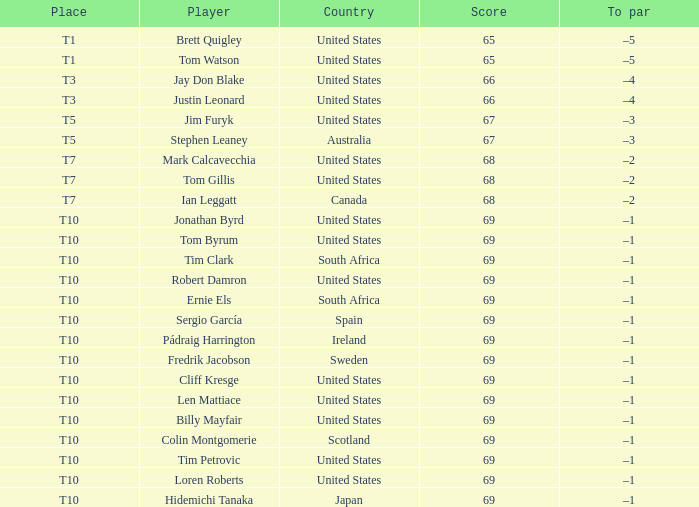Which player is T3? Jay Don Blake, Justin Leonard. 